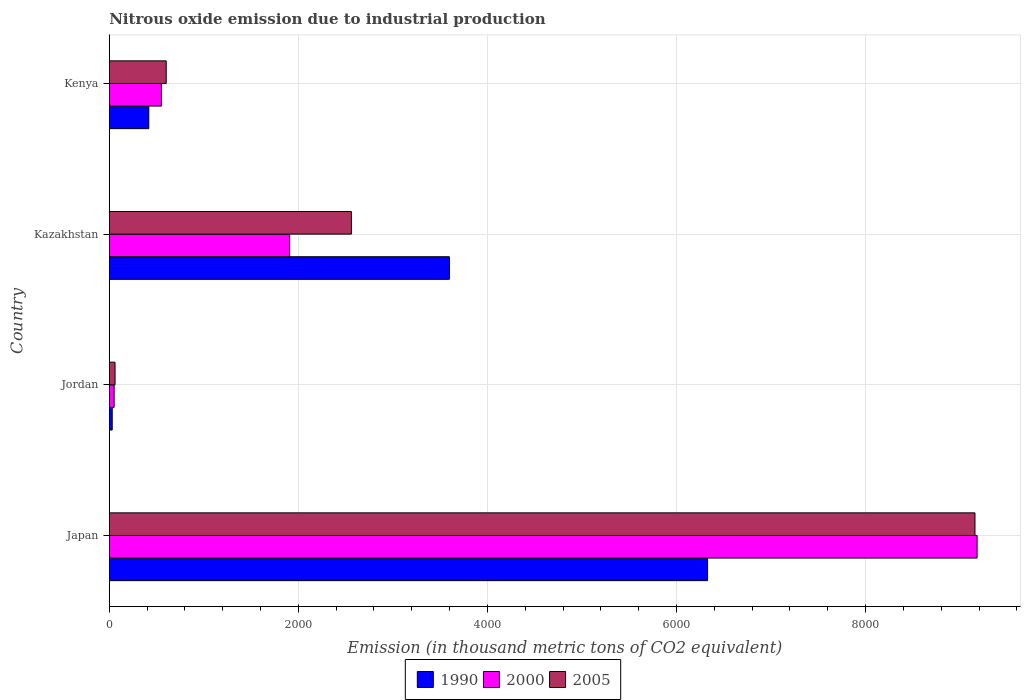How many different coloured bars are there?
Give a very brief answer. 3. Are the number of bars per tick equal to the number of legend labels?
Make the answer very short. Yes. Are the number of bars on each tick of the Y-axis equal?
Keep it short and to the point. Yes. How many bars are there on the 2nd tick from the bottom?
Your answer should be compact. 3. What is the label of the 3rd group of bars from the top?
Keep it short and to the point. Jordan. In how many cases, is the number of bars for a given country not equal to the number of legend labels?
Provide a short and direct response. 0. What is the amount of nitrous oxide emitted in 1990 in Jordan?
Your response must be concise. 31.2. Across all countries, what is the maximum amount of nitrous oxide emitted in 2000?
Make the answer very short. 9179.4. Across all countries, what is the minimum amount of nitrous oxide emitted in 1990?
Give a very brief answer. 31.2. In which country was the amount of nitrous oxide emitted in 2005 maximum?
Your answer should be compact. Japan. In which country was the amount of nitrous oxide emitted in 1990 minimum?
Offer a terse response. Jordan. What is the total amount of nitrous oxide emitted in 2000 in the graph?
Offer a very short reply. 1.17e+04. What is the difference between the amount of nitrous oxide emitted in 2000 in Japan and that in Jordan?
Offer a very short reply. 9128.1. What is the difference between the amount of nitrous oxide emitted in 1990 in Jordan and the amount of nitrous oxide emitted in 2005 in Japan?
Offer a terse response. -9125.8. What is the average amount of nitrous oxide emitted in 2005 per country?
Provide a short and direct response. 3095.42. What is the difference between the amount of nitrous oxide emitted in 2005 and amount of nitrous oxide emitted in 2000 in Kenya?
Provide a short and direct response. 50.9. In how many countries, is the amount of nitrous oxide emitted in 2005 greater than 400 thousand metric tons?
Ensure brevity in your answer.  3. What is the ratio of the amount of nitrous oxide emitted in 2000 in Jordan to that in Kenya?
Keep it short and to the point. 0.09. Is the difference between the amount of nitrous oxide emitted in 2005 in Japan and Kazakhstan greater than the difference between the amount of nitrous oxide emitted in 2000 in Japan and Kazakhstan?
Your answer should be very brief. No. What is the difference between the highest and the second highest amount of nitrous oxide emitted in 1990?
Your answer should be very brief. 2730.7. What is the difference between the highest and the lowest amount of nitrous oxide emitted in 2000?
Give a very brief answer. 9128.1. Is it the case that in every country, the sum of the amount of nitrous oxide emitted in 1990 and amount of nitrous oxide emitted in 2005 is greater than the amount of nitrous oxide emitted in 2000?
Offer a very short reply. Yes. How many bars are there?
Offer a terse response. 12. How many countries are there in the graph?
Provide a succinct answer. 4. Are the values on the major ticks of X-axis written in scientific E-notation?
Offer a very short reply. No. Does the graph contain any zero values?
Offer a very short reply. No. Does the graph contain grids?
Keep it short and to the point. Yes. What is the title of the graph?
Give a very brief answer. Nitrous oxide emission due to industrial production. Does "1976" appear as one of the legend labels in the graph?
Your answer should be compact. No. What is the label or title of the X-axis?
Your answer should be very brief. Emission (in thousand metric tons of CO2 equivalent). What is the Emission (in thousand metric tons of CO2 equivalent) in 1990 in Japan?
Give a very brief answer. 6328.4. What is the Emission (in thousand metric tons of CO2 equivalent) of 2000 in Japan?
Offer a terse response. 9179.4. What is the Emission (in thousand metric tons of CO2 equivalent) in 2005 in Japan?
Keep it short and to the point. 9157. What is the Emission (in thousand metric tons of CO2 equivalent) in 1990 in Jordan?
Offer a very short reply. 31.2. What is the Emission (in thousand metric tons of CO2 equivalent) of 2000 in Jordan?
Offer a very short reply. 51.3. What is the Emission (in thousand metric tons of CO2 equivalent) of 2005 in Jordan?
Provide a short and direct response. 61.1. What is the Emission (in thousand metric tons of CO2 equivalent) in 1990 in Kazakhstan?
Give a very brief answer. 3597.7. What is the Emission (in thousand metric tons of CO2 equivalent) in 2000 in Kazakhstan?
Offer a very short reply. 1908.3. What is the Emission (in thousand metric tons of CO2 equivalent) of 2005 in Kazakhstan?
Provide a succinct answer. 2561.2. What is the Emission (in thousand metric tons of CO2 equivalent) of 1990 in Kenya?
Give a very brief answer. 418. What is the Emission (in thousand metric tons of CO2 equivalent) of 2000 in Kenya?
Keep it short and to the point. 551.5. What is the Emission (in thousand metric tons of CO2 equivalent) in 2005 in Kenya?
Offer a terse response. 602.4. Across all countries, what is the maximum Emission (in thousand metric tons of CO2 equivalent) in 1990?
Ensure brevity in your answer.  6328.4. Across all countries, what is the maximum Emission (in thousand metric tons of CO2 equivalent) of 2000?
Keep it short and to the point. 9179.4. Across all countries, what is the maximum Emission (in thousand metric tons of CO2 equivalent) in 2005?
Your response must be concise. 9157. Across all countries, what is the minimum Emission (in thousand metric tons of CO2 equivalent) of 1990?
Make the answer very short. 31.2. Across all countries, what is the minimum Emission (in thousand metric tons of CO2 equivalent) in 2000?
Ensure brevity in your answer.  51.3. Across all countries, what is the minimum Emission (in thousand metric tons of CO2 equivalent) of 2005?
Give a very brief answer. 61.1. What is the total Emission (in thousand metric tons of CO2 equivalent) of 1990 in the graph?
Offer a very short reply. 1.04e+04. What is the total Emission (in thousand metric tons of CO2 equivalent) of 2000 in the graph?
Provide a succinct answer. 1.17e+04. What is the total Emission (in thousand metric tons of CO2 equivalent) of 2005 in the graph?
Your answer should be compact. 1.24e+04. What is the difference between the Emission (in thousand metric tons of CO2 equivalent) in 1990 in Japan and that in Jordan?
Make the answer very short. 6297.2. What is the difference between the Emission (in thousand metric tons of CO2 equivalent) of 2000 in Japan and that in Jordan?
Provide a succinct answer. 9128.1. What is the difference between the Emission (in thousand metric tons of CO2 equivalent) of 2005 in Japan and that in Jordan?
Provide a succinct answer. 9095.9. What is the difference between the Emission (in thousand metric tons of CO2 equivalent) of 1990 in Japan and that in Kazakhstan?
Your answer should be very brief. 2730.7. What is the difference between the Emission (in thousand metric tons of CO2 equivalent) of 2000 in Japan and that in Kazakhstan?
Offer a very short reply. 7271.1. What is the difference between the Emission (in thousand metric tons of CO2 equivalent) of 2005 in Japan and that in Kazakhstan?
Provide a short and direct response. 6595.8. What is the difference between the Emission (in thousand metric tons of CO2 equivalent) of 1990 in Japan and that in Kenya?
Ensure brevity in your answer.  5910.4. What is the difference between the Emission (in thousand metric tons of CO2 equivalent) in 2000 in Japan and that in Kenya?
Keep it short and to the point. 8627.9. What is the difference between the Emission (in thousand metric tons of CO2 equivalent) in 2005 in Japan and that in Kenya?
Give a very brief answer. 8554.6. What is the difference between the Emission (in thousand metric tons of CO2 equivalent) in 1990 in Jordan and that in Kazakhstan?
Your answer should be very brief. -3566.5. What is the difference between the Emission (in thousand metric tons of CO2 equivalent) of 2000 in Jordan and that in Kazakhstan?
Make the answer very short. -1857. What is the difference between the Emission (in thousand metric tons of CO2 equivalent) in 2005 in Jordan and that in Kazakhstan?
Ensure brevity in your answer.  -2500.1. What is the difference between the Emission (in thousand metric tons of CO2 equivalent) of 1990 in Jordan and that in Kenya?
Offer a terse response. -386.8. What is the difference between the Emission (in thousand metric tons of CO2 equivalent) of 2000 in Jordan and that in Kenya?
Your response must be concise. -500.2. What is the difference between the Emission (in thousand metric tons of CO2 equivalent) in 2005 in Jordan and that in Kenya?
Offer a terse response. -541.3. What is the difference between the Emission (in thousand metric tons of CO2 equivalent) of 1990 in Kazakhstan and that in Kenya?
Ensure brevity in your answer.  3179.7. What is the difference between the Emission (in thousand metric tons of CO2 equivalent) of 2000 in Kazakhstan and that in Kenya?
Your answer should be very brief. 1356.8. What is the difference between the Emission (in thousand metric tons of CO2 equivalent) in 2005 in Kazakhstan and that in Kenya?
Give a very brief answer. 1958.8. What is the difference between the Emission (in thousand metric tons of CO2 equivalent) in 1990 in Japan and the Emission (in thousand metric tons of CO2 equivalent) in 2000 in Jordan?
Your response must be concise. 6277.1. What is the difference between the Emission (in thousand metric tons of CO2 equivalent) of 1990 in Japan and the Emission (in thousand metric tons of CO2 equivalent) of 2005 in Jordan?
Keep it short and to the point. 6267.3. What is the difference between the Emission (in thousand metric tons of CO2 equivalent) in 2000 in Japan and the Emission (in thousand metric tons of CO2 equivalent) in 2005 in Jordan?
Provide a short and direct response. 9118.3. What is the difference between the Emission (in thousand metric tons of CO2 equivalent) in 1990 in Japan and the Emission (in thousand metric tons of CO2 equivalent) in 2000 in Kazakhstan?
Your answer should be very brief. 4420.1. What is the difference between the Emission (in thousand metric tons of CO2 equivalent) of 1990 in Japan and the Emission (in thousand metric tons of CO2 equivalent) of 2005 in Kazakhstan?
Make the answer very short. 3767.2. What is the difference between the Emission (in thousand metric tons of CO2 equivalent) of 2000 in Japan and the Emission (in thousand metric tons of CO2 equivalent) of 2005 in Kazakhstan?
Your answer should be compact. 6618.2. What is the difference between the Emission (in thousand metric tons of CO2 equivalent) of 1990 in Japan and the Emission (in thousand metric tons of CO2 equivalent) of 2000 in Kenya?
Make the answer very short. 5776.9. What is the difference between the Emission (in thousand metric tons of CO2 equivalent) in 1990 in Japan and the Emission (in thousand metric tons of CO2 equivalent) in 2005 in Kenya?
Give a very brief answer. 5726. What is the difference between the Emission (in thousand metric tons of CO2 equivalent) of 2000 in Japan and the Emission (in thousand metric tons of CO2 equivalent) of 2005 in Kenya?
Offer a terse response. 8577. What is the difference between the Emission (in thousand metric tons of CO2 equivalent) in 1990 in Jordan and the Emission (in thousand metric tons of CO2 equivalent) in 2000 in Kazakhstan?
Your response must be concise. -1877.1. What is the difference between the Emission (in thousand metric tons of CO2 equivalent) of 1990 in Jordan and the Emission (in thousand metric tons of CO2 equivalent) of 2005 in Kazakhstan?
Ensure brevity in your answer.  -2530. What is the difference between the Emission (in thousand metric tons of CO2 equivalent) in 2000 in Jordan and the Emission (in thousand metric tons of CO2 equivalent) in 2005 in Kazakhstan?
Offer a very short reply. -2509.9. What is the difference between the Emission (in thousand metric tons of CO2 equivalent) in 1990 in Jordan and the Emission (in thousand metric tons of CO2 equivalent) in 2000 in Kenya?
Keep it short and to the point. -520.3. What is the difference between the Emission (in thousand metric tons of CO2 equivalent) of 1990 in Jordan and the Emission (in thousand metric tons of CO2 equivalent) of 2005 in Kenya?
Your answer should be compact. -571.2. What is the difference between the Emission (in thousand metric tons of CO2 equivalent) in 2000 in Jordan and the Emission (in thousand metric tons of CO2 equivalent) in 2005 in Kenya?
Keep it short and to the point. -551.1. What is the difference between the Emission (in thousand metric tons of CO2 equivalent) in 1990 in Kazakhstan and the Emission (in thousand metric tons of CO2 equivalent) in 2000 in Kenya?
Offer a terse response. 3046.2. What is the difference between the Emission (in thousand metric tons of CO2 equivalent) of 1990 in Kazakhstan and the Emission (in thousand metric tons of CO2 equivalent) of 2005 in Kenya?
Provide a short and direct response. 2995.3. What is the difference between the Emission (in thousand metric tons of CO2 equivalent) in 2000 in Kazakhstan and the Emission (in thousand metric tons of CO2 equivalent) in 2005 in Kenya?
Provide a short and direct response. 1305.9. What is the average Emission (in thousand metric tons of CO2 equivalent) of 1990 per country?
Offer a very short reply. 2593.82. What is the average Emission (in thousand metric tons of CO2 equivalent) of 2000 per country?
Make the answer very short. 2922.62. What is the average Emission (in thousand metric tons of CO2 equivalent) of 2005 per country?
Offer a terse response. 3095.43. What is the difference between the Emission (in thousand metric tons of CO2 equivalent) in 1990 and Emission (in thousand metric tons of CO2 equivalent) in 2000 in Japan?
Give a very brief answer. -2851. What is the difference between the Emission (in thousand metric tons of CO2 equivalent) in 1990 and Emission (in thousand metric tons of CO2 equivalent) in 2005 in Japan?
Keep it short and to the point. -2828.6. What is the difference between the Emission (in thousand metric tons of CO2 equivalent) of 2000 and Emission (in thousand metric tons of CO2 equivalent) of 2005 in Japan?
Your answer should be very brief. 22.4. What is the difference between the Emission (in thousand metric tons of CO2 equivalent) in 1990 and Emission (in thousand metric tons of CO2 equivalent) in 2000 in Jordan?
Provide a succinct answer. -20.1. What is the difference between the Emission (in thousand metric tons of CO2 equivalent) in 1990 and Emission (in thousand metric tons of CO2 equivalent) in 2005 in Jordan?
Offer a terse response. -29.9. What is the difference between the Emission (in thousand metric tons of CO2 equivalent) of 1990 and Emission (in thousand metric tons of CO2 equivalent) of 2000 in Kazakhstan?
Your answer should be compact. 1689.4. What is the difference between the Emission (in thousand metric tons of CO2 equivalent) in 1990 and Emission (in thousand metric tons of CO2 equivalent) in 2005 in Kazakhstan?
Your answer should be compact. 1036.5. What is the difference between the Emission (in thousand metric tons of CO2 equivalent) in 2000 and Emission (in thousand metric tons of CO2 equivalent) in 2005 in Kazakhstan?
Offer a very short reply. -652.9. What is the difference between the Emission (in thousand metric tons of CO2 equivalent) of 1990 and Emission (in thousand metric tons of CO2 equivalent) of 2000 in Kenya?
Make the answer very short. -133.5. What is the difference between the Emission (in thousand metric tons of CO2 equivalent) of 1990 and Emission (in thousand metric tons of CO2 equivalent) of 2005 in Kenya?
Offer a very short reply. -184.4. What is the difference between the Emission (in thousand metric tons of CO2 equivalent) in 2000 and Emission (in thousand metric tons of CO2 equivalent) in 2005 in Kenya?
Give a very brief answer. -50.9. What is the ratio of the Emission (in thousand metric tons of CO2 equivalent) in 1990 in Japan to that in Jordan?
Give a very brief answer. 202.83. What is the ratio of the Emission (in thousand metric tons of CO2 equivalent) in 2000 in Japan to that in Jordan?
Offer a very short reply. 178.94. What is the ratio of the Emission (in thousand metric tons of CO2 equivalent) in 2005 in Japan to that in Jordan?
Make the answer very short. 149.87. What is the ratio of the Emission (in thousand metric tons of CO2 equivalent) of 1990 in Japan to that in Kazakhstan?
Your response must be concise. 1.76. What is the ratio of the Emission (in thousand metric tons of CO2 equivalent) of 2000 in Japan to that in Kazakhstan?
Offer a terse response. 4.81. What is the ratio of the Emission (in thousand metric tons of CO2 equivalent) in 2005 in Japan to that in Kazakhstan?
Your answer should be very brief. 3.58. What is the ratio of the Emission (in thousand metric tons of CO2 equivalent) of 1990 in Japan to that in Kenya?
Your answer should be compact. 15.14. What is the ratio of the Emission (in thousand metric tons of CO2 equivalent) of 2000 in Japan to that in Kenya?
Provide a short and direct response. 16.64. What is the ratio of the Emission (in thousand metric tons of CO2 equivalent) of 2005 in Japan to that in Kenya?
Provide a succinct answer. 15.2. What is the ratio of the Emission (in thousand metric tons of CO2 equivalent) of 1990 in Jordan to that in Kazakhstan?
Offer a very short reply. 0.01. What is the ratio of the Emission (in thousand metric tons of CO2 equivalent) of 2000 in Jordan to that in Kazakhstan?
Offer a terse response. 0.03. What is the ratio of the Emission (in thousand metric tons of CO2 equivalent) of 2005 in Jordan to that in Kazakhstan?
Your response must be concise. 0.02. What is the ratio of the Emission (in thousand metric tons of CO2 equivalent) of 1990 in Jordan to that in Kenya?
Make the answer very short. 0.07. What is the ratio of the Emission (in thousand metric tons of CO2 equivalent) of 2000 in Jordan to that in Kenya?
Your response must be concise. 0.09. What is the ratio of the Emission (in thousand metric tons of CO2 equivalent) of 2005 in Jordan to that in Kenya?
Your answer should be very brief. 0.1. What is the ratio of the Emission (in thousand metric tons of CO2 equivalent) in 1990 in Kazakhstan to that in Kenya?
Your answer should be compact. 8.61. What is the ratio of the Emission (in thousand metric tons of CO2 equivalent) in 2000 in Kazakhstan to that in Kenya?
Your answer should be very brief. 3.46. What is the ratio of the Emission (in thousand metric tons of CO2 equivalent) of 2005 in Kazakhstan to that in Kenya?
Provide a succinct answer. 4.25. What is the difference between the highest and the second highest Emission (in thousand metric tons of CO2 equivalent) in 1990?
Your response must be concise. 2730.7. What is the difference between the highest and the second highest Emission (in thousand metric tons of CO2 equivalent) of 2000?
Keep it short and to the point. 7271.1. What is the difference between the highest and the second highest Emission (in thousand metric tons of CO2 equivalent) in 2005?
Give a very brief answer. 6595.8. What is the difference between the highest and the lowest Emission (in thousand metric tons of CO2 equivalent) of 1990?
Ensure brevity in your answer.  6297.2. What is the difference between the highest and the lowest Emission (in thousand metric tons of CO2 equivalent) of 2000?
Your answer should be very brief. 9128.1. What is the difference between the highest and the lowest Emission (in thousand metric tons of CO2 equivalent) of 2005?
Provide a succinct answer. 9095.9. 